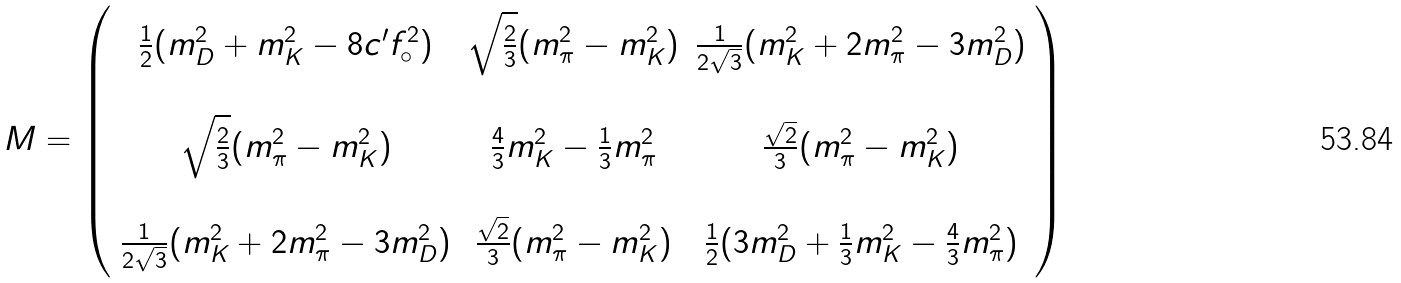<formula> <loc_0><loc_0><loc_500><loc_500>M = \left ( \begin{array} { c c c } \frac { 1 } { 2 } ( m _ { D } ^ { 2 } + m _ { K } ^ { 2 } - 8 c ^ { \prime } f _ { \circ } ^ { 2 } ) & \sqrt { \frac { 2 } { 3 } } ( m _ { \pi } ^ { 2 } - m _ { K } ^ { 2 } ) & \frac { 1 } { 2 \sqrt { 3 } } ( m _ { K } ^ { 2 } + 2 m _ { \pi } ^ { 2 } - 3 m _ { D } ^ { 2 } ) \\ & & \\ \sqrt { \frac { 2 } { 3 } } ( m _ { \pi } ^ { 2 } - m _ { K } ^ { 2 } ) & \frac { 4 } { 3 } m _ { K } ^ { 2 } - \frac { 1 } { 3 } m _ { \pi } ^ { 2 } & \frac { \sqrt { 2 } } { 3 } ( m _ { \pi } ^ { 2 } - m _ { K } ^ { 2 } ) \\ & & \\ \frac { 1 } { 2 \sqrt { 3 } } ( m _ { K } ^ { 2 } + 2 m _ { \pi } ^ { 2 } - 3 m _ { D } ^ { 2 } ) & \frac { \sqrt { 2 } } { 3 } ( m _ { \pi } ^ { 2 } - m _ { K } ^ { 2 } ) & \frac { 1 } { 2 } ( 3 m _ { D } ^ { 2 } + \frac { 1 } { 3 } m _ { K } ^ { 2 } - \frac { 4 } { 3 } m _ { \pi } ^ { 2 } ) \end{array} \right )</formula> 